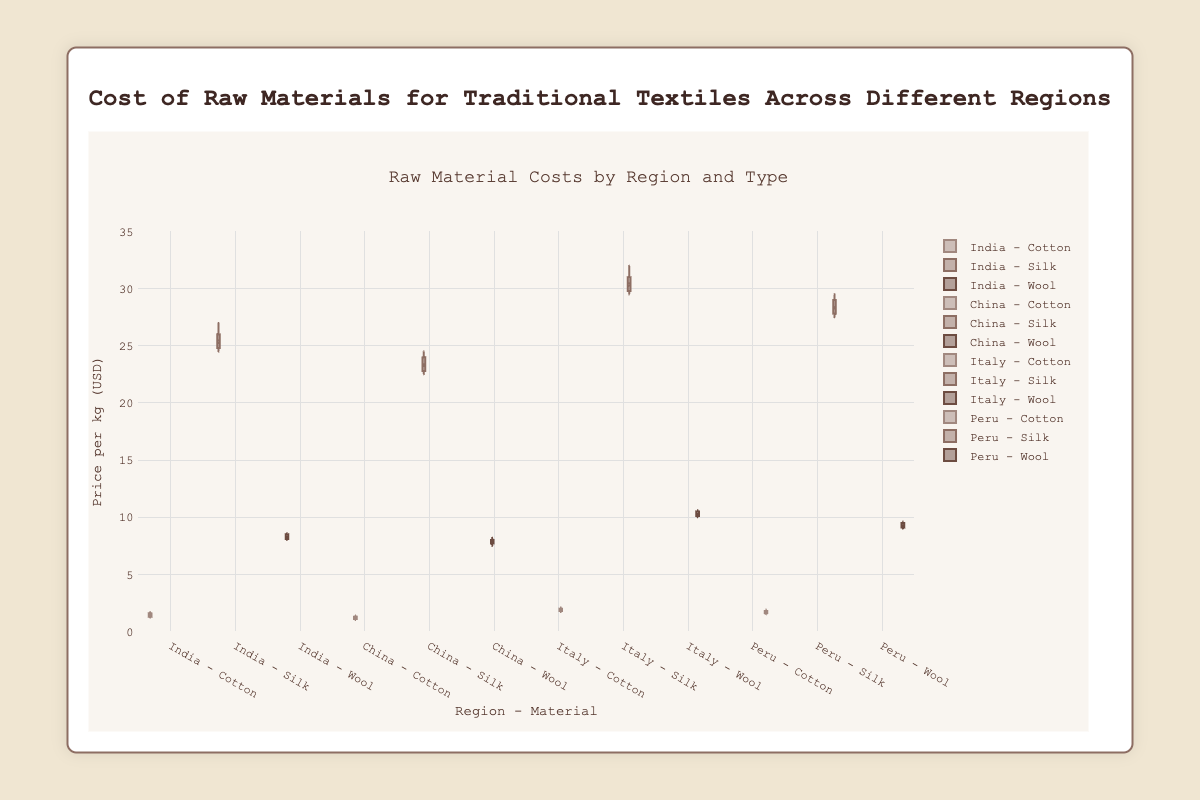What is the title of the figure? The title is displayed at the top center of the figure in larger, bold font. It summarizes the information presented in the chart.
Answer: Cost of Raw Materials for Traditional Textiles Across Different Regions How many regions are displayed in the figure? Count the distinct groups along the x-axis, each representing a different region.
Answer: 4 Which raw material has the highest median price in Italy? Look at the median line inside the box for each material in the Italy group. The highest median line indicates the material with the highest median price.
Answer: Silk What is the range of cotton prices in India? Find the highest and lowest points (whiskers) for the cotton box plot in the India group and calculate the difference between them.
Answer: 1.7 - 1.2 = 0.5 Which region has the lowest median price for wool? Compare the median lines inside the boxes for wool across all regions. The region with the lowest median line indicates the lowest median price for wool.
Answer: China How do the median prices of cotton compare between India and Peru? Identify and compare the median lines within the boxes for cotton in India and Peru.
Answer: Peru's median price is higher than India's What's the interquartile range (IQR) of silk prices in China? The IQR is the difference between the third quartile (top of the box) and the first quartile (bottom of the box) in the silk box plot for China.
Answer: 24.0 - 22.5 = 1.5 Which raw material shows the greatest variation in prices within a single region? Look for the box plot with the largest distance between the whiskers within each region to identify the material with the greatest variation.
Answer: Silk in Italy Is the price distribution of wool in Peru more or less spread out compared to China? Compare the length of the whiskers in the wool box plots for Peru and China to assess if the distribution is more or less spread out.
Answer: The distribution in Peru is more spread out than in China Which raw material has generally higher prices across all regions? Observe the overall position of the boxes and their medians for each material across all regions.
Answer: Silk 